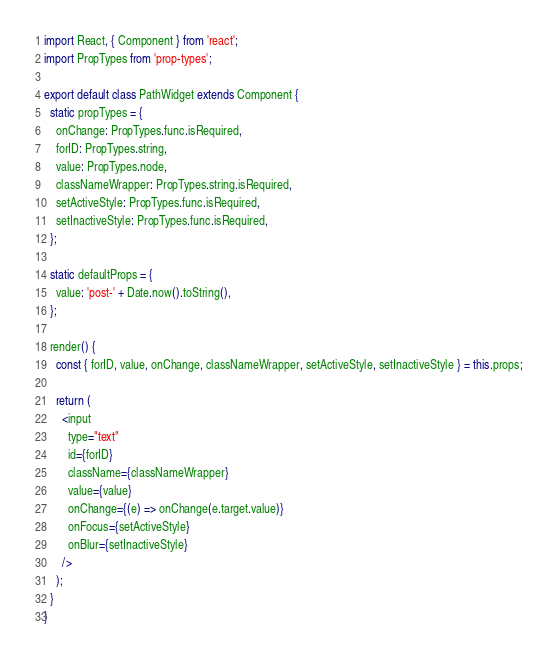Convert code to text. <code><loc_0><loc_0><loc_500><loc_500><_JavaScript_>import React, { Component } from 'react';
import PropTypes from 'prop-types';

export default class PathWidget extends Component {
  static propTypes = {
    onChange: PropTypes.func.isRequired,
    forID: PropTypes.string,
    value: PropTypes.node,
    classNameWrapper: PropTypes.string.isRequired,
    setActiveStyle: PropTypes.func.isRequired,
    setInactiveStyle: PropTypes.func.isRequired,
  };

  static defaultProps = {
    value: 'post-' + Date.now().toString(),
  };

  render() {
    const { forID, value, onChange, classNameWrapper, setActiveStyle, setInactiveStyle } = this.props;

    return (
      <input
        type="text"
        id={forID}
        className={classNameWrapper}
        value={value}
        onChange={(e) => onChange(e.target.value)}
        onFocus={setActiveStyle}
        onBlur={setInactiveStyle}
      />
    );
  }
}
</code> 